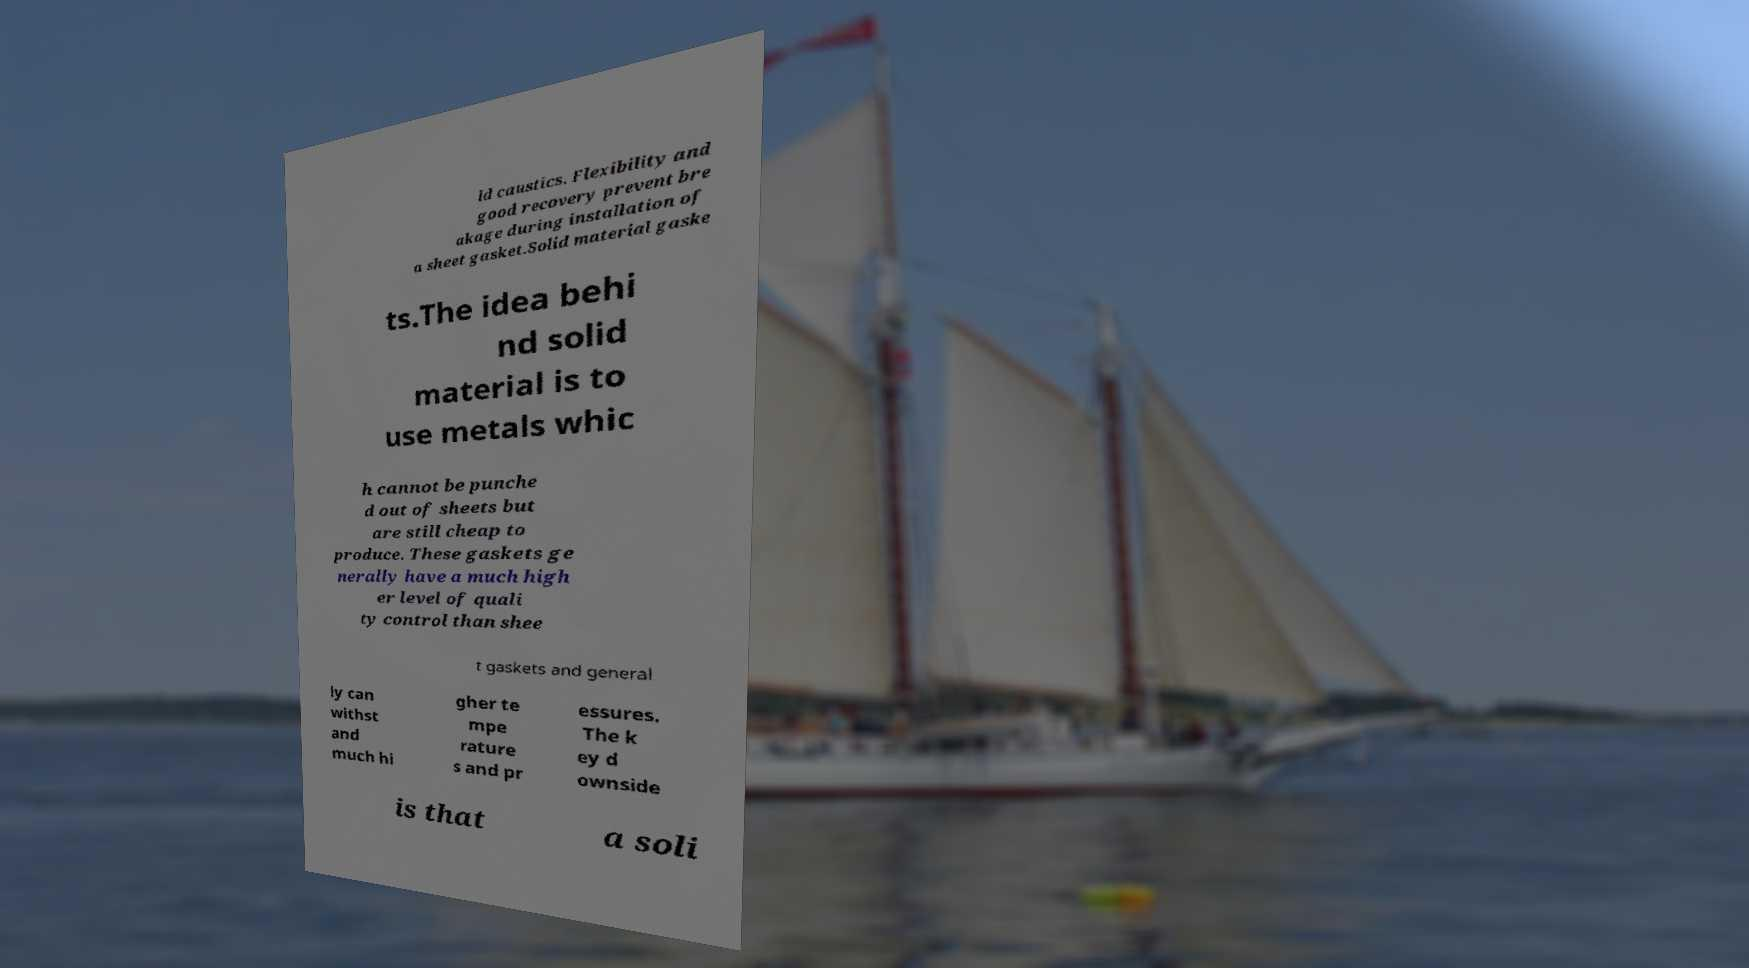Can you accurately transcribe the text from the provided image for me? ld caustics. Flexibility and good recovery prevent bre akage during installation of a sheet gasket.Solid material gaske ts.The idea behi nd solid material is to use metals whic h cannot be punche d out of sheets but are still cheap to produce. These gaskets ge nerally have a much high er level of quali ty control than shee t gaskets and general ly can withst and much hi gher te mpe rature s and pr essures. The k ey d ownside is that a soli 